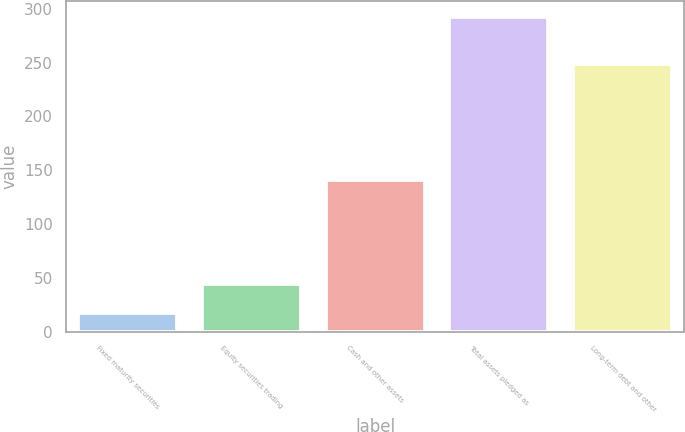Convert chart. <chart><loc_0><loc_0><loc_500><loc_500><bar_chart><fcel>Fixed maturity securities<fcel>Equity securities trading<fcel>Cash and other assets<fcel>Total assets pledged as<fcel>Long-term debt and other<nl><fcel>17.2<fcel>44.73<fcel>140.8<fcel>292.5<fcel>248.6<nl></chart> 